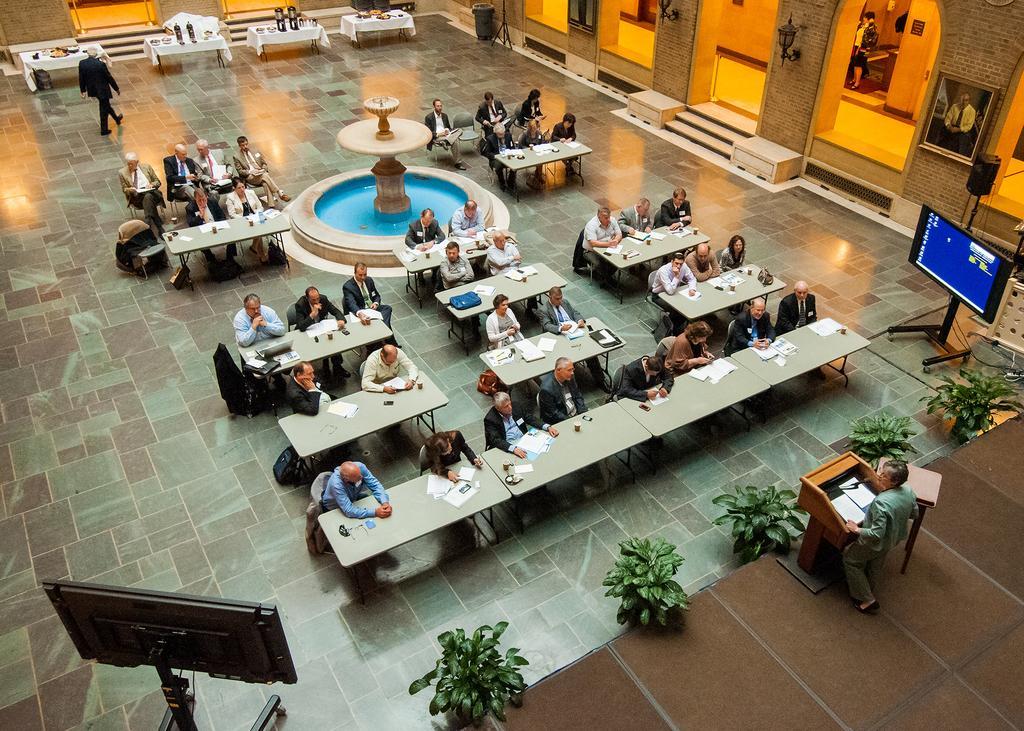Could you give a brief overview of what you see in this image? In this image I can see group of people sitting, I can also see few papers, bags on the tables and I can see a person standing in front of the podium, I can also see two screens, few plants in green color. Background I can see few lights attached to the wall and I can also see few frames. 